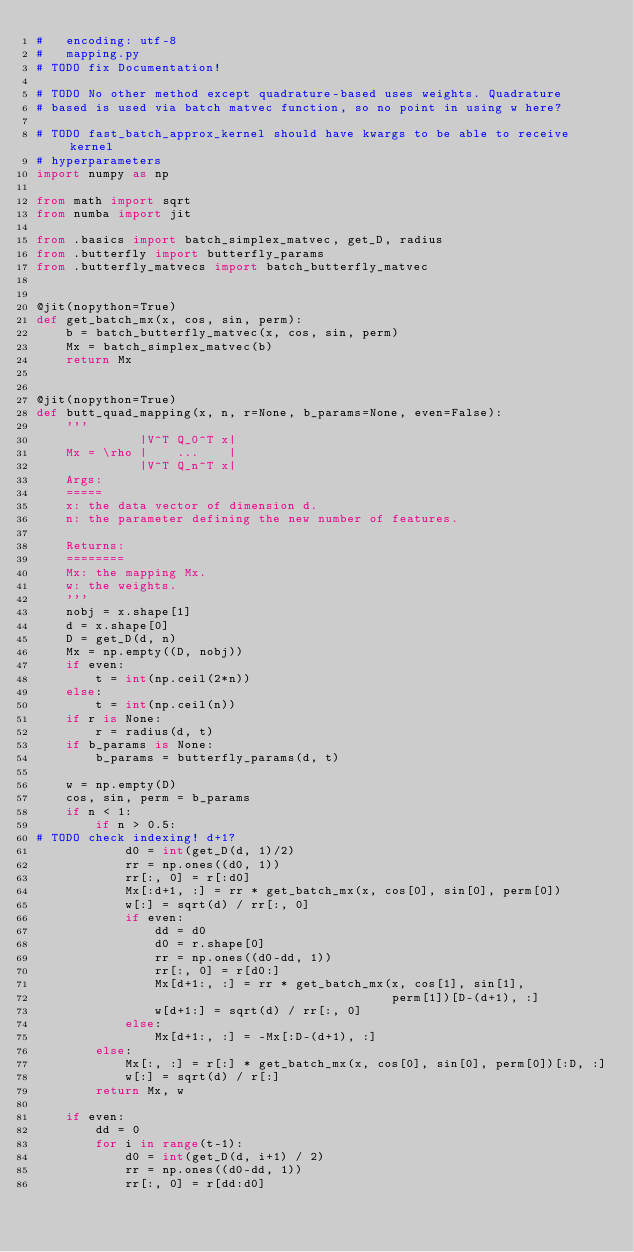Convert code to text. <code><loc_0><loc_0><loc_500><loc_500><_Python_>#   encoding: utf-8
#   mapping.py
# TODO fix Documentation!

# TODO No other method except quadrature-based uses weights. Quadrature
# based is used via batch matvec function, so no point in using w here?

# TODO fast_batch_approx_kernel should have kwargs to be able to receive kernel
# hyperparameters
import numpy as np

from math import sqrt
from numba import jit

from .basics import batch_simplex_matvec, get_D, radius
from .butterfly import butterfly_params
from .butterfly_matvecs import batch_butterfly_matvec


@jit(nopython=True)
def get_batch_mx(x, cos, sin, perm):
    b = batch_butterfly_matvec(x, cos, sin, perm)
    Mx = batch_simplex_matvec(b)
    return Mx


@jit(nopython=True)
def butt_quad_mapping(x, n, r=None, b_params=None, even=False):
    '''
              |V^T Q_0^T x|
    Mx = \rho |    ...    |
              |V^T Q_n^T x|
    Args:
    =====
    x: the data vector of dimension d.
    n: the parameter defining the new number of features.

    Returns:
    ========
    Mx: the mapping Mx.
    w: the weights.
    '''
    nobj = x.shape[1]
    d = x.shape[0]
    D = get_D(d, n)
    Mx = np.empty((D, nobj))
    if even:
        t = int(np.ceil(2*n))
    else:
        t = int(np.ceil(n))
    if r is None:
        r = radius(d, t)
    if b_params is None:
        b_params = butterfly_params(d, t)

    w = np.empty(D)
    cos, sin, perm = b_params
    if n < 1:
        if n > 0.5:
# TODO check indexing! d+1?
            d0 = int(get_D(d, 1)/2)
            rr = np.ones((d0, 1))
            rr[:, 0] = r[:d0]
            Mx[:d+1, :] = rr * get_batch_mx(x, cos[0], sin[0], perm[0])
            w[:] = sqrt(d) / rr[:, 0]
            if even:
                dd = d0
                d0 = r.shape[0]
                rr = np.ones((d0-dd, 1))
                rr[:, 0] = r[d0:]
                Mx[d+1:, :] = rr * get_batch_mx(x, cos[1], sin[1],
                                                perm[1])[D-(d+1), :]
                w[d+1:] = sqrt(d) / rr[:, 0]
            else:
                Mx[d+1:, :] = -Mx[:D-(d+1), :]
        else:
            Mx[:, :] = r[:] * get_batch_mx(x, cos[0], sin[0], perm[0])[:D, :]
            w[:] = sqrt(d) / r[:]
        return Mx, w

    if even:
        dd = 0
        for i in range(t-1):
            d0 = int(get_D(d, i+1) / 2)
            rr = np.ones((d0-dd, 1))
            rr[:, 0] = r[dd:d0]</code> 